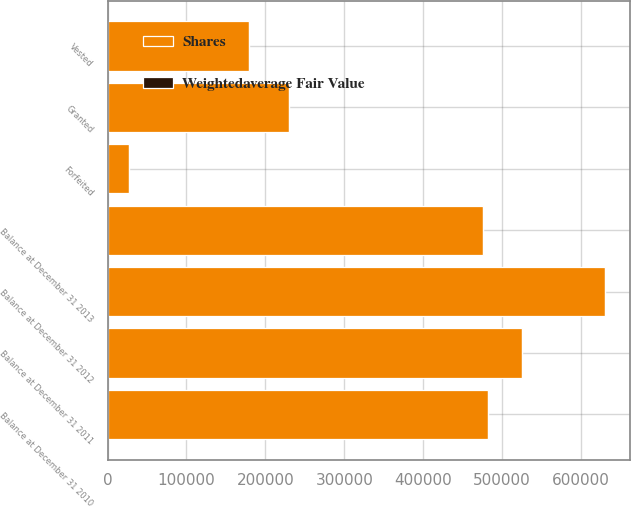Convert chart to OTSL. <chart><loc_0><loc_0><loc_500><loc_500><stacked_bar_chart><ecel><fcel>Balance at December 31 2010<fcel>Granted<fcel>Vested<fcel>Balance at December 31 2011<fcel>Balance at December 31 2012<fcel>Forfeited<fcel>Balance at December 31 2013<nl><fcel>Shares<fcel>481771<fcel>229436<fcel>178653<fcel>525391<fcel>630084<fcel>26938<fcel>475913<nl><fcel>Weightedaverage Fair Value<fcel>45.1<fcel>86.65<fcel>48.03<fcel>62.05<fcel>86.49<fcel>85.07<fcel>109.93<nl></chart> 